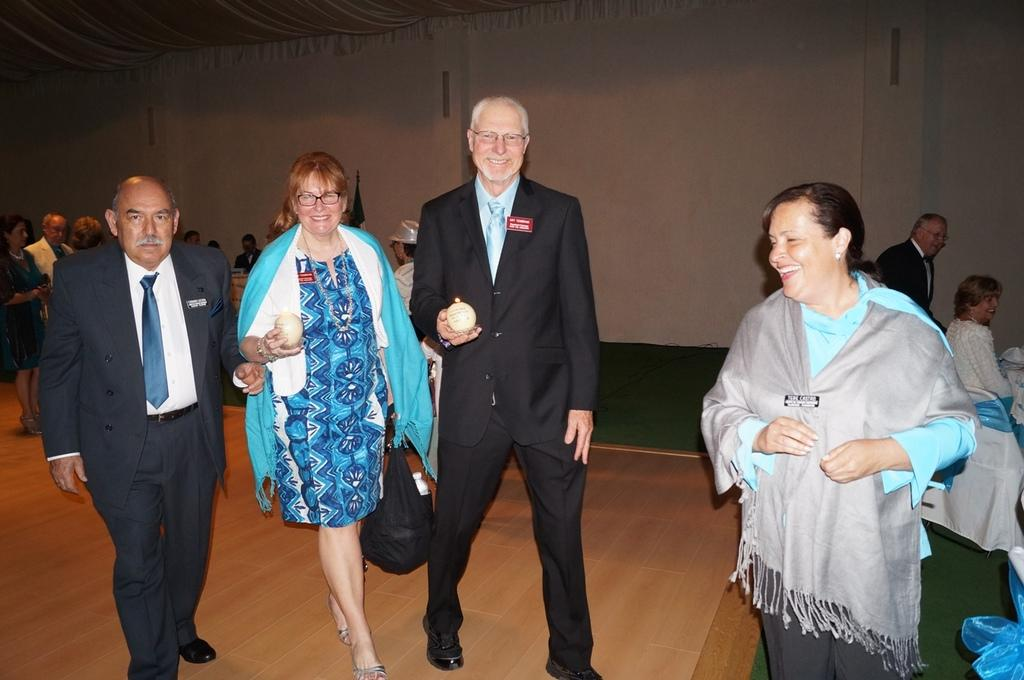How many people are in the image? There is a group of people in the image, but the exact number is not specified. What are the people doing in the image? The people are on the floor in the image. What can be seen in the background of the image? There is a wall visible in the background of the image. What type of joke is being told by the fan in the image? There is no fan or joke present in the image. How does the steam affect the people on the floor in the image? There is no steam present in the image, so it cannot affect the people on the floor. 